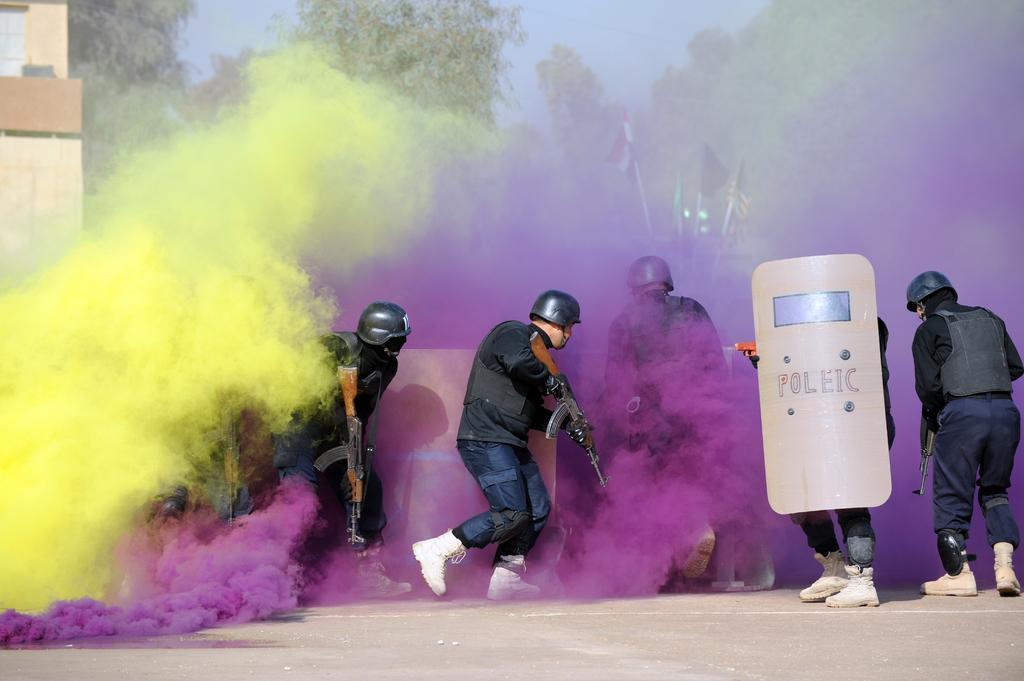How would you summarize this image in a sentence or two? In this image there are people holding guns and sheets standing on a road and there are colors, in the background there are trees, flags, buildings and the sky. 